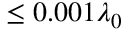Convert formula to latex. <formula><loc_0><loc_0><loc_500><loc_500>\leq 0 . 0 0 1 \lambda _ { 0 }</formula> 